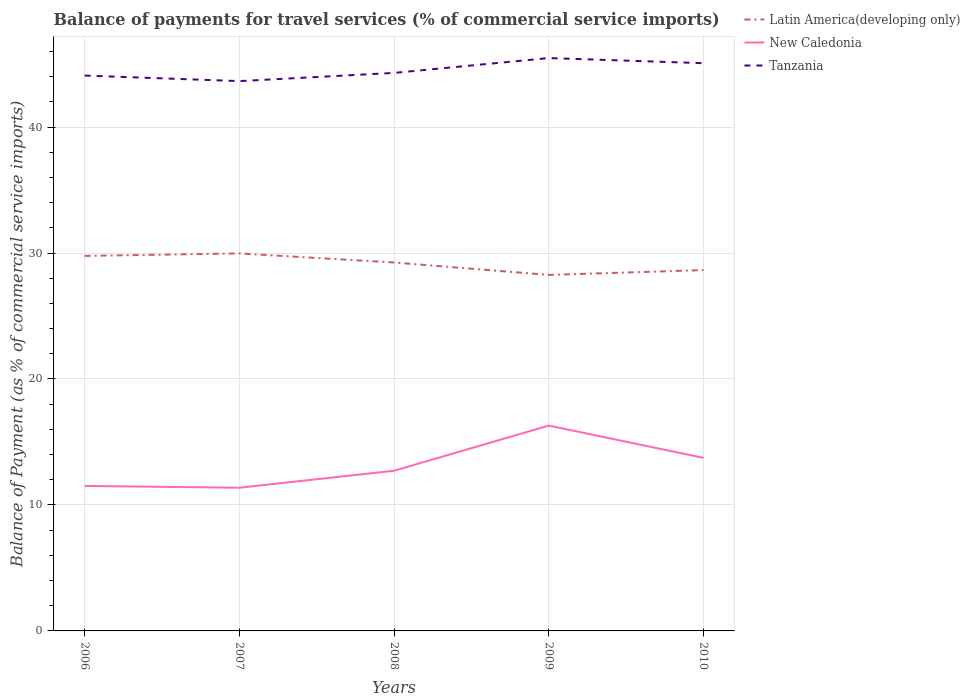How many different coloured lines are there?
Provide a short and direct response. 3. Does the line corresponding to Tanzania intersect with the line corresponding to Latin America(developing only)?
Provide a succinct answer. No. Across all years, what is the maximum balance of payments for travel services in Tanzania?
Offer a terse response. 43.65. What is the total balance of payments for travel services in Tanzania in the graph?
Give a very brief answer. -1.18. What is the difference between the highest and the second highest balance of payments for travel services in New Caledonia?
Your response must be concise. 4.93. What is the difference between the highest and the lowest balance of payments for travel services in New Caledonia?
Your response must be concise. 2. How many lines are there?
Make the answer very short. 3. What is the difference between two consecutive major ticks on the Y-axis?
Keep it short and to the point. 10. Are the values on the major ticks of Y-axis written in scientific E-notation?
Keep it short and to the point. No. Where does the legend appear in the graph?
Keep it short and to the point. Top right. How many legend labels are there?
Ensure brevity in your answer.  3. How are the legend labels stacked?
Give a very brief answer. Vertical. What is the title of the graph?
Make the answer very short. Balance of payments for travel services (% of commercial service imports). What is the label or title of the Y-axis?
Offer a terse response. Balance of Payment (as % of commercial service imports). What is the Balance of Payment (as % of commercial service imports) of Latin America(developing only) in 2006?
Your answer should be compact. 29.77. What is the Balance of Payment (as % of commercial service imports) in New Caledonia in 2006?
Provide a short and direct response. 11.51. What is the Balance of Payment (as % of commercial service imports) in Tanzania in 2006?
Ensure brevity in your answer.  44.09. What is the Balance of Payment (as % of commercial service imports) in Latin America(developing only) in 2007?
Make the answer very short. 29.97. What is the Balance of Payment (as % of commercial service imports) of New Caledonia in 2007?
Offer a terse response. 11.37. What is the Balance of Payment (as % of commercial service imports) of Tanzania in 2007?
Keep it short and to the point. 43.65. What is the Balance of Payment (as % of commercial service imports) in Latin America(developing only) in 2008?
Your response must be concise. 29.25. What is the Balance of Payment (as % of commercial service imports) of New Caledonia in 2008?
Your response must be concise. 12.72. What is the Balance of Payment (as % of commercial service imports) in Tanzania in 2008?
Give a very brief answer. 44.3. What is the Balance of Payment (as % of commercial service imports) in Latin America(developing only) in 2009?
Provide a short and direct response. 28.26. What is the Balance of Payment (as % of commercial service imports) in New Caledonia in 2009?
Offer a very short reply. 16.3. What is the Balance of Payment (as % of commercial service imports) in Tanzania in 2009?
Your response must be concise. 45.48. What is the Balance of Payment (as % of commercial service imports) in Latin America(developing only) in 2010?
Keep it short and to the point. 28.65. What is the Balance of Payment (as % of commercial service imports) in New Caledonia in 2010?
Make the answer very short. 13.74. What is the Balance of Payment (as % of commercial service imports) of Tanzania in 2010?
Offer a very short reply. 45.07. Across all years, what is the maximum Balance of Payment (as % of commercial service imports) in Latin America(developing only)?
Ensure brevity in your answer.  29.97. Across all years, what is the maximum Balance of Payment (as % of commercial service imports) in New Caledonia?
Provide a short and direct response. 16.3. Across all years, what is the maximum Balance of Payment (as % of commercial service imports) in Tanzania?
Provide a succinct answer. 45.48. Across all years, what is the minimum Balance of Payment (as % of commercial service imports) in Latin America(developing only)?
Your response must be concise. 28.26. Across all years, what is the minimum Balance of Payment (as % of commercial service imports) in New Caledonia?
Give a very brief answer. 11.37. Across all years, what is the minimum Balance of Payment (as % of commercial service imports) of Tanzania?
Offer a very short reply. 43.65. What is the total Balance of Payment (as % of commercial service imports) in Latin America(developing only) in the graph?
Make the answer very short. 145.89. What is the total Balance of Payment (as % of commercial service imports) in New Caledonia in the graph?
Provide a succinct answer. 65.63. What is the total Balance of Payment (as % of commercial service imports) in Tanzania in the graph?
Ensure brevity in your answer.  222.58. What is the difference between the Balance of Payment (as % of commercial service imports) of Latin America(developing only) in 2006 and that in 2007?
Offer a very short reply. -0.2. What is the difference between the Balance of Payment (as % of commercial service imports) of New Caledonia in 2006 and that in 2007?
Your response must be concise. 0.14. What is the difference between the Balance of Payment (as % of commercial service imports) in Tanzania in 2006 and that in 2007?
Provide a short and direct response. 0.44. What is the difference between the Balance of Payment (as % of commercial service imports) of Latin America(developing only) in 2006 and that in 2008?
Make the answer very short. 0.52. What is the difference between the Balance of Payment (as % of commercial service imports) in New Caledonia in 2006 and that in 2008?
Your answer should be compact. -1.21. What is the difference between the Balance of Payment (as % of commercial service imports) in Tanzania in 2006 and that in 2008?
Make the answer very short. -0.21. What is the difference between the Balance of Payment (as % of commercial service imports) of Latin America(developing only) in 2006 and that in 2009?
Your answer should be compact. 1.51. What is the difference between the Balance of Payment (as % of commercial service imports) of New Caledonia in 2006 and that in 2009?
Your answer should be very brief. -4.79. What is the difference between the Balance of Payment (as % of commercial service imports) of Tanzania in 2006 and that in 2009?
Give a very brief answer. -1.39. What is the difference between the Balance of Payment (as % of commercial service imports) of Latin America(developing only) in 2006 and that in 2010?
Ensure brevity in your answer.  1.13. What is the difference between the Balance of Payment (as % of commercial service imports) in New Caledonia in 2006 and that in 2010?
Offer a very short reply. -2.23. What is the difference between the Balance of Payment (as % of commercial service imports) in Tanzania in 2006 and that in 2010?
Your answer should be very brief. -0.98. What is the difference between the Balance of Payment (as % of commercial service imports) in Latin America(developing only) in 2007 and that in 2008?
Provide a short and direct response. 0.72. What is the difference between the Balance of Payment (as % of commercial service imports) in New Caledonia in 2007 and that in 2008?
Your answer should be compact. -1.35. What is the difference between the Balance of Payment (as % of commercial service imports) of Tanzania in 2007 and that in 2008?
Keep it short and to the point. -0.65. What is the difference between the Balance of Payment (as % of commercial service imports) in Latin America(developing only) in 2007 and that in 2009?
Make the answer very short. 1.71. What is the difference between the Balance of Payment (as % of commercial service imports) in New Caledonia in 2007 and that in 2009?
Your answer should be very brief. -4.93. What is the difference between the Balance of Payment (as % of commercial service imports) of Tanzania in 2007 and that in 2009?
Give a very brief answer. -1.83. What is the difference between the Balance of Payment (as % of commercial service imports) in Latin America(developing only) in 2007 and that in 2010?
Make the answer very short. 1.32. What is the difference between the Balance of Payment (as % of commercial service imports) of New Caledonia in 2007 and that in 2010?
Provide a short and direct response. -2.37. What is the difference between the Balance of Payment (as % of commercial service imports) of Tanzania in 2007 and that in 2010?
Your response must be concise. -1.42. What is the difference between the Balance of Payment (as % of commercial service imports) of New Caledonia in 2008 and that in 2009?
Your response must be concise. -3.58. What is the difference between the Balance of Payment (as % of commercial service imports) of Tanzania in 2008 and that in 2009?
Provide a succinct answer. -1.18. What is the difference between the Balance of Payment (as % of commercial service imports) of Latin America(developing only) in 2008 and that in 2010?
Provide a succinct answer. 0.6. What is the difference between the Balance of Payment (as % of commercial service imports) of New Caledonia in 2008 and that in 2010?
Keep it short and to the point. -1.02. What is the difference between the Balance of Payment (as % of commercial service imports) of Tanzania in 2008 and that in 2010?
Offer a very short reply. -0.77. What is the difference between the Balance of Payment (as % of commercial service imports) in Latin America(developing only) in 2009 and that in 2010?
Give a very brief answer. -0.39. What is the difference between the Balance of Payment (as % of commercial service imports) of New Caledonia in 2009 and that in 2010?
Provide a succinct answer. 2.56. What is the difference between the Balance of Payment (as % of commercial service imports) in Tanzania in 2009 and that in 2010?
Provide a succinct answer. 0.41. What is the difference between the Balance of Payment (as % of commercial service imports) in Latin America(developing only) in 2006 and the Balance of Payment (as % of commercial service imports) in New Caledonia in 2007?
Ensure brevity in your answer.  18.4. What is the difference between the Balance of Payment (as % of commercial service imports) in Latin America(developing only) in 2006 and the Balance of Payment (as % of commercial service imports) in Tanzania in 2007?
Give a very brief answer. -13.87. What is the difference between the Balance of Payment (as % of commercial service imports) in New Caledonia in 2006 and the Balance of Payment (as % of commercial service imports) in Tanzania in 2007?
Make the answer very short. -32.14. What is the difference between the Balance of Payment (as % of commercial service imports) in Latin America(developing only) in 2006 and the Balance of Payment (as % of commercial service imports) in New Caledonia in 2008?
Provide a succinct answer. 17.05. What is the difference between the Balance of Payment (as % of commercial service imports) of Latin America(developing only) in 2006 and the Balance of Payment (as % of commercial service imports) of Tanzania in 2008?
Keep it short and to the point. -14.53. What is the difference between the Balance of Payment (as % of commercial service imports) of New Caledonia in 2006 and the Balance of Payment (as % of commercial service imports) of Tanzania in 2008?
Provide a succinct answer. -32.79. What is the difference between the Balance of Payment (as % of commercial service imports) of Latin America(developing only) in 2006 and the Balance of Payment (as % of commercial service imports) of New Caledonia in 2009?
Keep it short and to the point. 13.47. What is the difference between the Balance of Payment (as % of commercial service imports) of Latin America(developing only) in 2006 and the Balance of Payment (as % of commercial service imports) of Tanzania in 2009?
Your response must be concise. -15.71. What is the difference between the Balance of Payment (as % of commercial service imports) in New Caledonia in 2006 and the Balance of Payment (as % of commercial service imports) in Tanzania in 2009?
Make the answer very short. -33.97. What is the difference between the Balance of Payment (as % of commercial service imports) of Latin America(developing only) in 2006 and the Balance of Payment (as % of commercial service imports) of New Caledonia in 2010?
Offer a terse response. 16.03. What is the difference between the Balance of Payment (as % of commercial service imports) of Latin America(developing only) in 2006 and the Balance of Payment (as % of commercial service imports) of Tanzania in 2010?
Provide a short and direct response. -15.3. What is the difference between the Balance of Payment (as % of commercial service imports) of New Caledonia in 2006 and the Balance of Payment (as % of commercial service imports) of Tanzania in 2010?
Provide a succinct answer. -33.56. What is the difference between the Balance of Payment (as % of commercial service imports) of Latin America(developing only) in 2007 and the Balance of Payment (as % of commercial service imports) of New Caledonia in 2008?
Ensure brevity in your answer.  17.25. What is the difference between the Balance of Payment (as % of commercial service imports) of Latin America(developing only) in 2007 and the Balance of Payment (as % of commercial service imports) of Tanzania in 2008?
Keep it short and to the point. -14.33. What is the difference between the Balance of Payment (as % of commercial service imports) in New Caledonia in 2007 and the Balance of Payment (as % of commercial service imports) in Tanzania in 2008?
Provide a short and direct response. -32.93. What is the difference between the Balance of Payment (as % of commercial service imports) in Latin America(developing only) in 2007 and the Balance of Payment (as % of commercial service imports) in New Caledonia in 2009?
Keep it short and to the point. 13.67. What is the difference between the Balance of Payment (as % of commercial service imports) of Latin America(developing only) in 2007 and the Balance of Payment (as % of commercial service imports) of Tanzania in 2009?
Your answer should be compact. -15.51. What is the difference between the Balance of Payment (as % of commercial service imports) of New Caledonia in 2007 and the Balance of Payment (as % of commercial service imports) of Tanzania in 2009?
Make the answer very short. -34.11. What is the difference between the Balance of Payment (as % of commercial service imports) of Latin America(developing only) in 2007 and the Balance of Payment (as % of commercial service imports) of New Caledonia in 2010?
Give a very brief answer. 16.23. What is the difference between the Balance of Payment (as % of commercial service imports) in Latin America(developing only) in 2007 and the Balance of Payment (as % of commercial service imports) in Tanzania in 2010?
Your answer should be compact. -15.1. What is the difference between the Balance of Payment (as % of commercial service imports) in New Caledonia in 2007 and the Balance of Payment (as % of commercial service imports) in Tanzania in 2010?
Your answer should be compact. -33.7. What is the difference between the Balance of Payment (as % of commercial service imports) in Latin America(developing only) in 2008 and the Balance of Payment (as % of commercial service imports) in New Caledonia in 2009?
Keep it short and to the point. 12.95. What is the difference between the Balance of Payment (as % of commercial service imports) of Latin America(developing only) in 2008 and the Balance of Payment (as % of commercial service imports) of Tanzania in 2009?
Ensure brevity in your answer.  -16.23. What is the difference between the Balance of Payment (as % of commercial service imports) in New Caledonia in 2008 and the Balance of Payment (as % of commercial service imports) in Tanzania in 2009?
Keep it short and to the point. -32.76. What is the difference between the Balance of Payment (as % of commercial service imports) in Latin America(developing only) in 2008 and the Balance of Payment (as % of commercial service imports) in New Caledonia in 2010?
Your response must be concise. 15.51. What is the difference between the Balance of Payment (as % of commercial service imports) of Latin America(developing only) in 2008 and the Balance of Payment (as % of commercial service imports) of Tanzania in 2010?
Give a very brief answer. -15.82. What is the difference between the Balance of Payment (as % of commercial service imports) in New Caledonia in 2008 and the Balance of Payment (as % of commercial service imports) in Tanzania in 2010?
Provide a succinct answer. -32.35. What is the difference between the Balance of Payment (as % of commercial service imports) in Latin America(developing only) in 2009 and the Balance of Payment (as % of commercial service imports) in New Caledonia in 2010?
Your answer should be very brief. 14.52. What is the difference between the Balance of Payment (as % of commercial service imports) in Latin America(developing only) in 2009 and the Balance of Payment (as % of commercial service imports) in Tanzania in 2010?
Your answer should be compact. -16.81. What is the difference between the Balance of Payment (as % of commercial service imports) of New Caledonia in 2009 and the Balance of Payment (as % of commercial service imports) of Tanzania in 2010?
Make the answer very short. -28.77. What is the average Balance of Payment (as % of commercial service imports) of Latin America(developing only) per year?
Provide a short and direct response. 29.18. What is the average Balance of Payment (as % of commercial service imports) in New Caledonia per year?
Ensure brevity in your answer.  13.13. What is the average Balance of Payment (as % of commercial service imports) in Tanzania per year?
Offer a terse response. 44.52. In the year 2006, what is the difference between the Balance of Payment (as % of commercial service imports) of Latin America(developing only) and Balance of Payment (as % of commercial service imports) of New Caledonia?
Your answer should be compact. 18.26. In the year 2006, what is the difference between the Balance of Payment (as % of commercial service imports) of Latin America(developing only) and Balance of Payment (as % of commercial service imports) of Tanzania?
Provide a short and direct response. -14.32. In the year 2006, what is the difference between the Balance of Payment (as % of commercial service imports) in New Caledonia and Balance of Payment (as % of commercial service imports) in Tanzania?
Offer a terse response. -32.58. In the year 2007, what is the difference between the Balance of Payment (as % of commercial service imports) in Latin America(developing only) and Balance of Payment (as % of commercial service imports) in New Caledonia?
Ensure brevity in your answer.  18.6. In the year 2007, what is the difference between the Balance of Payment (as % of commercial service imports) of Latin America(developing only) and Balance of Payment (as % of commercial service imports) of Tanzania?
Offer a very short reply. -13.68. In the year 2007, what is the difference between the Balance of Payment (as % of commercial service imports) in New Caledonia and Balance of Payment (as % of commercial service imports) in Tanzania?
Provide a short and direct response. -32.28. In the year 2008, what is the difference between the Balance of Payment (as % of commercial service imports) in Latin America(developing only) and Balance of Payment (as % of commercial service imports) in New Caledonia?
Your answer should be compact. 16.53. In the year 2008, what is the difference between the Balance of Payment (as % of commercial service imports) of Latin America(developing only) and Balance of Payment (as % of commercial service imports) of Tanzania?
Keep it short and to the point. -15.05. In the year 2008, what is the difference between the Balance of Payment (as % of commercial service imports) in New Caledonia and Balance of Payment (as % of commercial service imports) in Tanzania?
Offer a very short reply. -31.58. In the year 2009, what is the difference between the Balance of Payment (as % of commercial service imports) in Latin America(developing only) and Balance of Payment (as % of commercial service imports) in New Caledonia?
Give a very brief answer. 11.96. In the year 2009, what is the difference between the Balance of Payment (as % of commercial service imports) in Latin America(developing only) and Balance of Payment (as % of commercial service imports) in Tanzania?
Keep it short and to the point. -17.22. In the year 2009, what is the difference between the Balance of Payment (as % of commercial service imports) in New Caledonia and Balance of Payment (as % of commercial service imports) in Tanzania?
Provide a short and direct response. -29.18. In the year 2010, what is the difference between the Balance of Payment (as % of commercial service imports) of Latin America(developing only) and Balance of Payment (as % of commercial service imports) of New Caledonia?
Make the answer very short. 14.91. In the year 2010, what is the difference between the Balance of Payment (as % of commercial service imports) in Latin America(developing only) and Balance of Payment (as % of commercial service imports) in Tanzania?
Give a very brief answer. -16.42. In the year 2010, what is the difference between the Balance of Payment (as % of commercial service imports) of New Caledonia and Balance of Payment (as % of commercial service imports) of Tanzania?
Ensure brevity in your answer.  -31.33. What is the ratio of the Balance of Payment (as % of commercial service imports) of New Caledonia in 2006 to that in 2007?
Ensure brevity in your answer.  1.01. What is the ratio of the Balance of Payment (as % of commercial service imports) of Latin America(developing only) in 2006 to that in 2008?
Your answer should be very brief. 1.02. What is the ratio of the Balance of Payment (as % of commercial service imports) of New Caledonia in 2006 to that in 2008?
Provide a succinct answer. 0.91. What is the ratio of the Balance of Payment (as % of commercial service imports) of Latin America(developing only) in 2006 to that in 2009?
Ensure brevity in your answer.  1.05. What is the ratio of the Balance of Payment (as % of commercial service imports) of New Caledonia in 2006 to that in 2009?
Provide a short and direct response. 0.71. What is the ratio of the Balance of Payment (as % of commercial service imports) of Tanzania in 2006 to that in 2009?
Provide a short and direct response. 0.97. What is the ratio of the Balance of Payment (as % of commercial service imports) in Latin America(developing only) in 2006 to that in 2010?
Keep it short and to the point. 1.04. What is the ratio of the Balance of Payment (as % of commercial service imports) in New Caledonia in 2006 to that in 2010?
Offer a terse response. 0.84. What is the ratio of the Balance of Payment (as % of commercial service imports) of Tanzania in 2006 to that in 2010?
Keep it short and to the point. 0.98. What is the ratio of the Balance of Payment (as % of commercial service imports) of Latin America(developing only) in 2007 to that in 2008?
Offer a very short reply. 1.02. What is the ratio of the Balance of Payment (as % of commercial service imports) in New Caledonia in 2007 to that in 2008?
Your answer should be compact. 0.89. What is the ratio of the Balance of Payment (as % of commercial service imports) of Latin America(developing only) in 2007 to that in 2009?
Keep it short and to the point. 1.06. What is the ratio of the Balance of Payment (as % of commercial service imports) in New Caledonia in 2007 to that in 2009?
Give a very brief answer. 0.7. What is the ratio of the Balance of Payment (as % of commercial service imports) of Tanzania in 2007 to that in 2009?
Make the answer very short. 0.96. What is the ratio of the Balance of Payment (as % of commercial service imports) in Latin America(developing only) in 2007 to that in 2010?
Your response must be concise. 1.05. What is the ratio of the Balance of Payment (as % of commercial service imports) in New Caledonia in 2007 to that in 2010?
Keep it short and to the point. 0.83. What is the ratio of the Balance of Payment (as % of commercial service imports) of Tanzania in 2007 to that in 2010?
Give a very brief answer. 0.97. What is the ratio of the Balance of Payment (as % of commercial service imports) in Latin America(developing only) in 2008 to that in 2009?
Provide a short and direct response. 1.03. What is the ratio of the Balance of Payment (as % of commercial service imports) of New Caledonia in 2008 to that in 2009?
Give a very brief answer. 0.78. What is the ratio of the Balance of Payment (as % of commercial service imports) in Tanzania in 2008 to that in 2009?
Your answer should be very brief. 0.97. What is the ratio of the Balance of Payment (as % of commercial service imports) of Latin America(developing only) in 2008 to that in 2010?
Make the answer very short. 1.02. What is the ratio of the Balance of Payment (as % of commercial service imports) of New Caledonia in 2008 to that in 2010?
Provide a short and direct response. 0.93. What is the ratio of the Balance of Payment (as % of commercial service imports) in Tanzania in 2008 to that in 2010?
Offer a terse response. 0.98. What is the ratio of the Balance of Payment (as % of commercial service imports) of Latin America(developing only) in 2009 to that in 2010?
Your answer should be compact. 0.99. What is the ratio of the Balance of Payment (as % of commercial service imports) in New Caledonia in 2009 to that in 2010?
Keep it short and to the point. 1.19. What is the difference between the highest and the second highest Balance of Payment (as % of commercial service imports) in Latin America(developing only)?
Offer a very short reply. 0.2. What is the difference between the highest and the second highest Balance of Payment (as % of commercial service imports) of New Caledonia?
Offer a very short reply. 2.56. What is the difference between the highest and the second highest Balance of Payment (as % of commercial service imports) of Tanzania?
Your answer should be compact. 0.41. What is the difference between the highest and the lowest Balance of Payment (as % of commercial service imports) of Latin America(developing only)?
Ensure brevity in your answer.  1.71. What is the difference between the highest and the lowest Balance of Payment (as % of commercial service imports) of New Caledonia?
Make the answer very short. 4.93. What is the difference between the highest and the lowest Balance of Payment (as % of commercial service imports) in Tanzania?
Offer a very short reply. 1.83. 